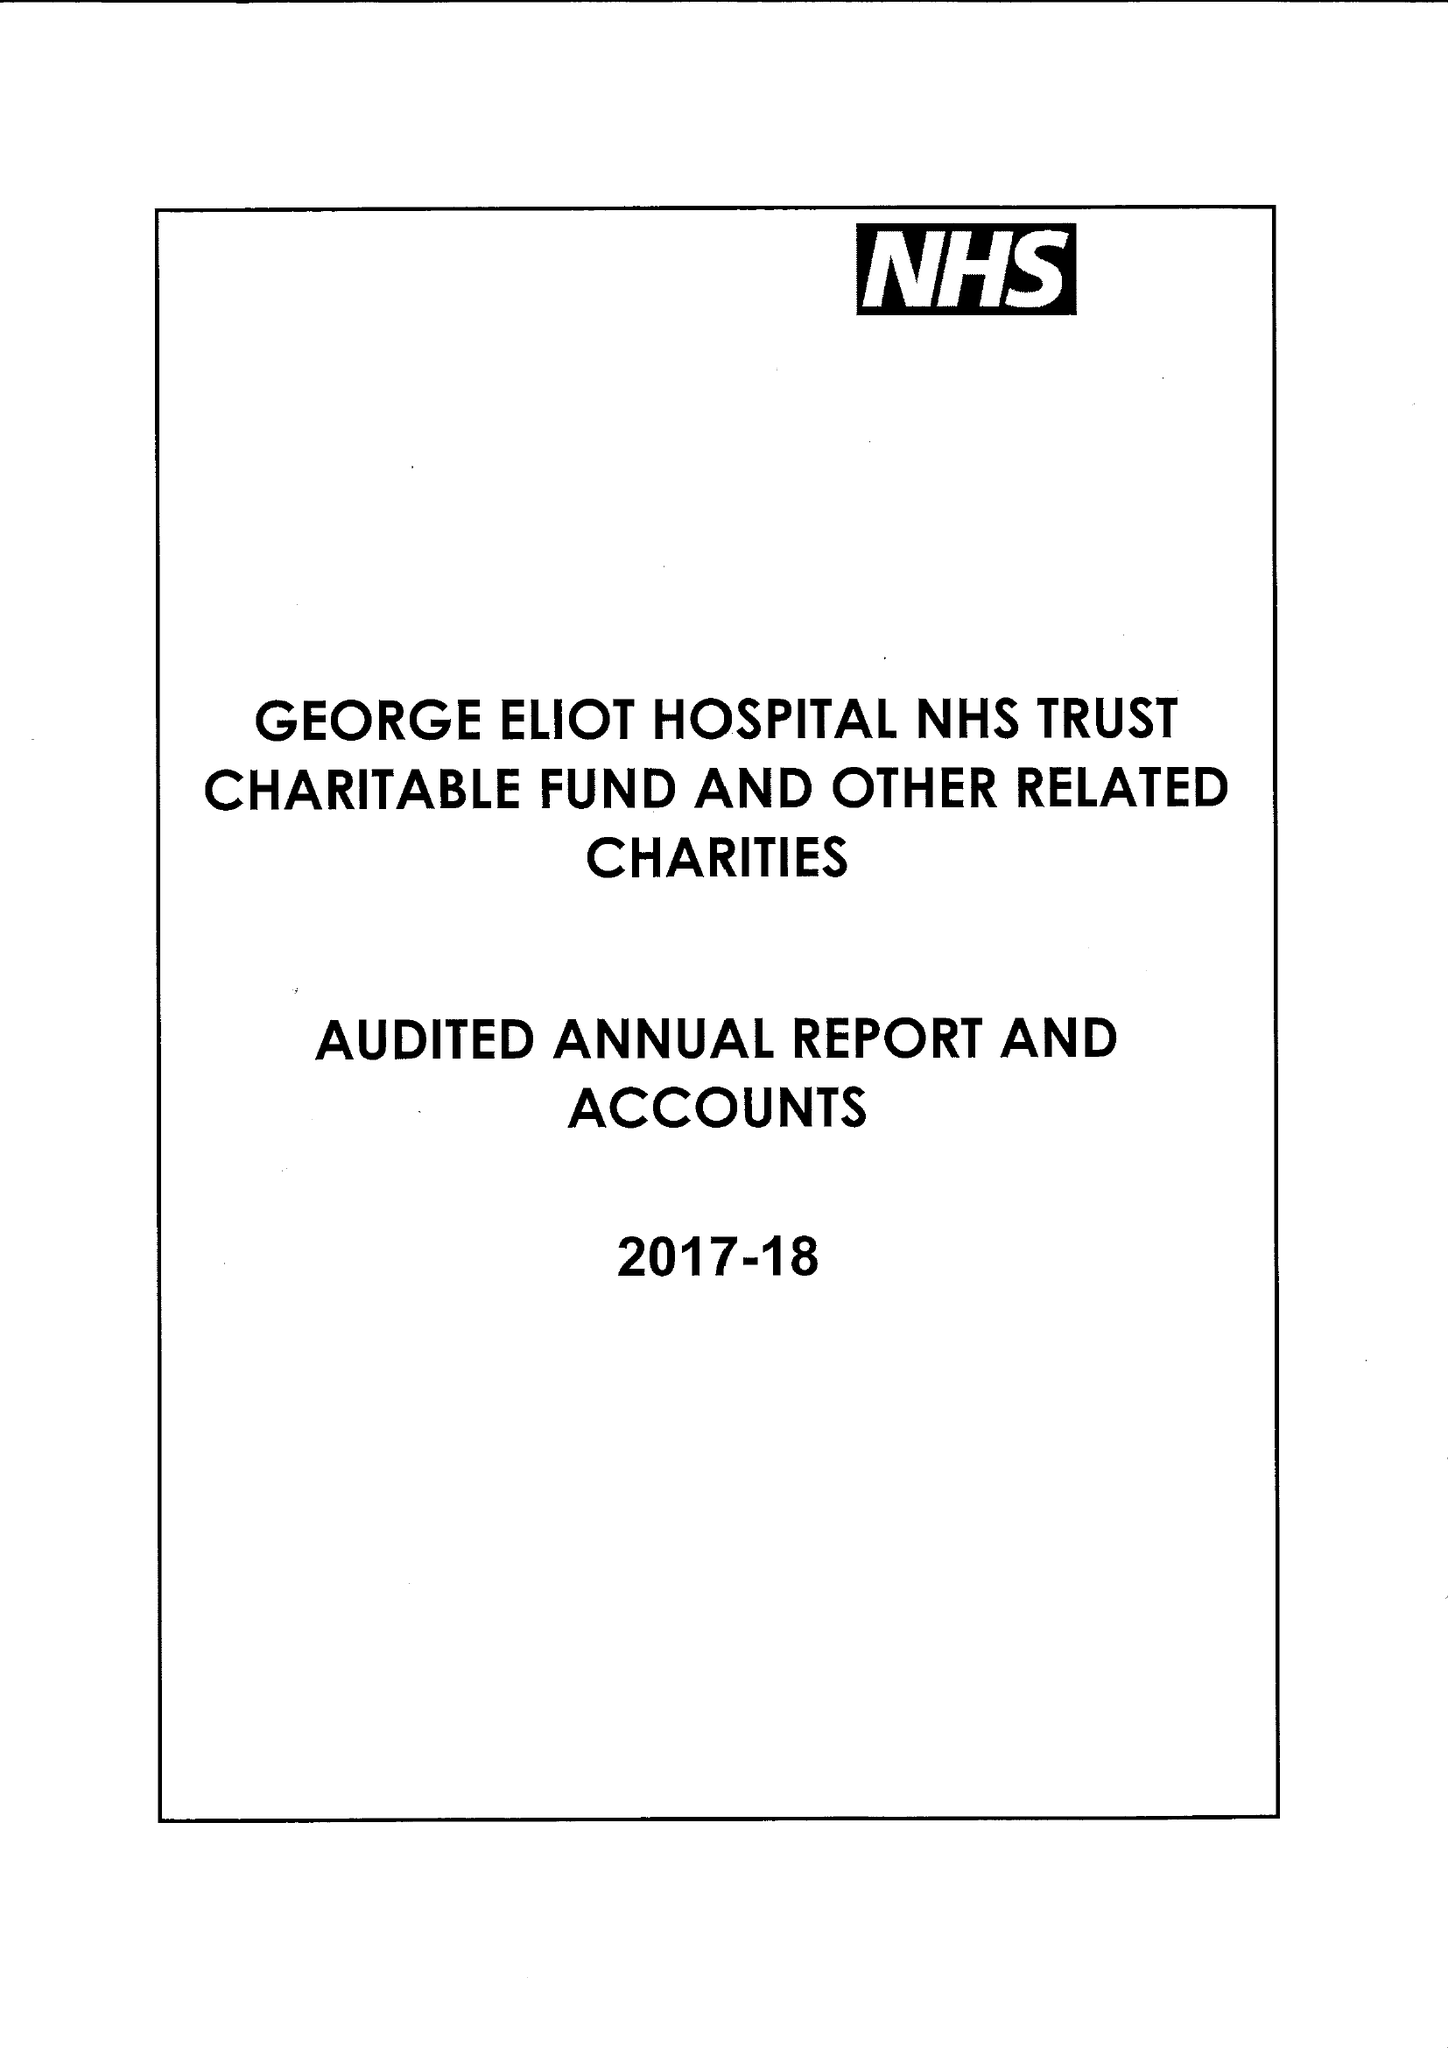What is the value for the report_date?
Answer the question using a single word or phrase. 2018-03-31 